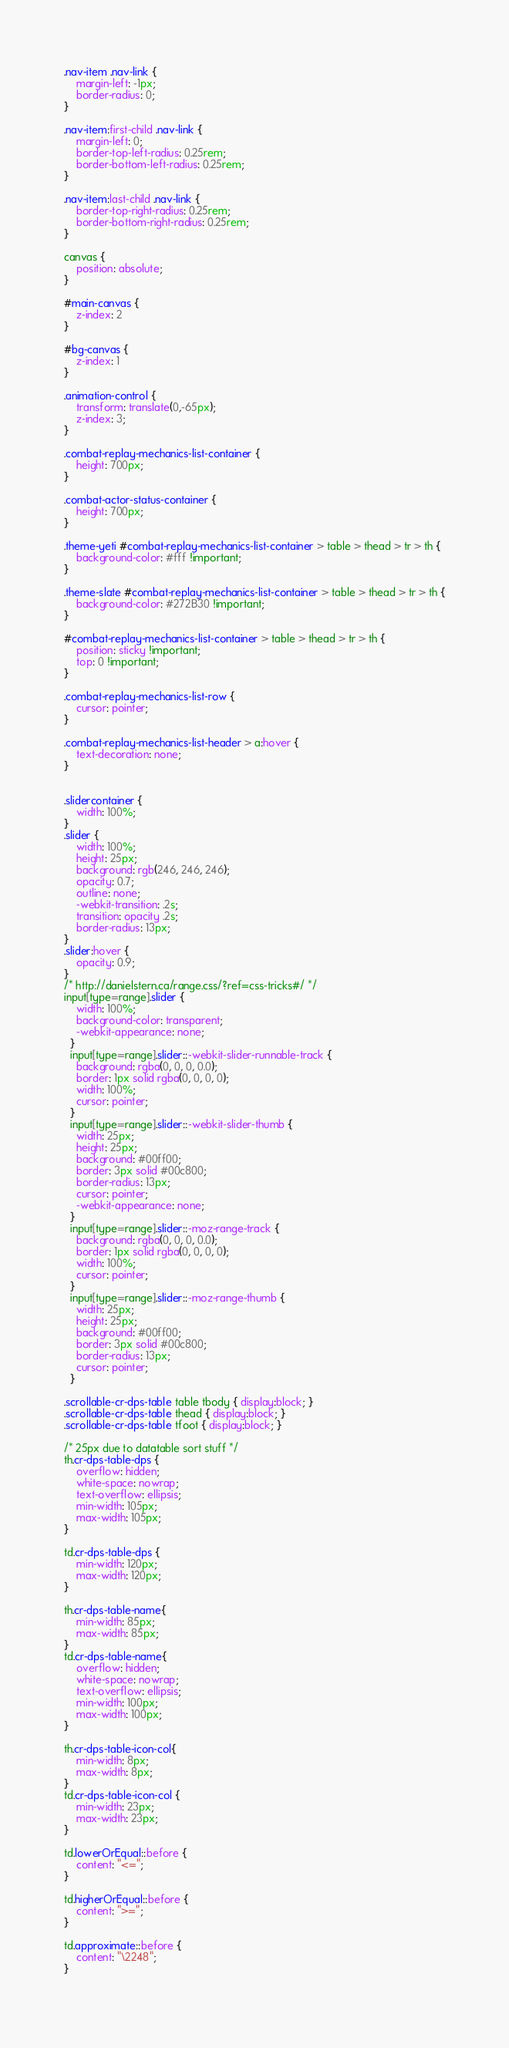Convert code to text. <code><loc_0><loc_0><loc_500><loc_500><_CSS_>.nav-item .nav-link {
    margin-left: -1px;
    border-radius: 0;
}

.nav-item:first-child .nav-link {
    margin-left: 0;
    border-top-left-radius: 0.25rem;
    border-bottom-left-radius: 0.25rem;
}

.nav-item:last-child .nav-link {
    border-top-right-radius: 0.25rem;
    border-bottom-right-radius: 0.25rem;
}

canvas {
    position: absolute;
}

#main-canvas {
    z-index: 2
}

#bg-canvas {
    z-index: 1
}

.animation-control {
    transform: translate(0,-65px);
    z-index: 3;
}

.combat-replay-mechanics-list-container {
    height: 700px;
}

.combat-actor-status-container {
    height: 700px;
}

.theme-yeti #combat-replay-mechanics-list-container > table > thead > tr > th {
    background-color: #fff !important;
}

.theme-slate #combat-replay-mechanics-list-container > table > thead > tr > th {
    background-color: #272B30 !important;
}

#combat-replay-mechanics-list-container > table > thead > tr > th {
    position: sticky !important;
    top: 0 !important;
}

.combat-replay-mechanics-list-row {
    cursor: pointer;
}

.combat-replay-mechanics-list-header > a:hover {
    text-decoration: none;
}


.slidercontainer {
    width: 100%;
}
.slider {
    width: 100%;
    height: 25px;
    background: rgb(246, 246, 246);
    opacity: 0.7;
    outline: none;
    -webkit-transition: .2s;
    transition: opacity .2s;
    border-radius: 13px;
}
.slider:hover {
    opacity: 0.9;
}
/* http://danielstern.ca/range.css/?ref=css-tricks#/ */
input[type=range].slider {
    width: 100%;
    background-color: transparent;
    -webkit-appearance: none;
  }
  input[type=range].slider::-webkit-slider-runnable-track {
    background: rgba(0, 0, 0, 0.0);
    border: 1px solid rgba(0, 0, 0, 0);
    width: 100%;
    cursor: pointer;
  }
  input[type=range].slider::-webkit-slider-thumb {
    width: 25px;
    height: 25px;
    background: #00ff00;
    border: 3px solid #00c800;
    border-radius: 13px;
    cursor: pointer;
    -webkit-appearance: none;
  }
  input[type=range].slider::-moz-range-track {
    background: rgba(0, 0, 0, 0.0);
    border: 1px solid rgba(0, 0, 0, 0);
    width: 100%;
    cursor: pointer;
  }
  input[type=range].slider::-moz-range-thumb {
    width: 25px;
    height: 25px;
    background: #00ff00;
    border: 3px solid #00c800;
    border-radius: 13px;
    cursor: pointer;
  }

.scrollable-cr-dps-table table tbody { display:block; }
.scrollable-cr-dps-table thead { display:block; }
.scrollable-cr-dps-table tfoot { display:block; }

/* 25px due to datatable sort stuff */
th.cr-dps-table-dps {
    overflow: hidden;
    white-space: nowrap;
    text-overflow: ellipsis;
    min-width: 105px;
    max-width: 105px;
}

td.cr-dps-table-dps {
    min-width: 120px;
    max-width: 120px;
}

th.cr-dps-table-name{
    min-width: 85px;
    max-width: 85px;
}
td.cr-dps-table-name{
    overflow: hidden;
    white-space: nowrap;
    text-overflow: ellipsis;
    min-width: 100px;
    max-width: 100px;
}

th.cr-dps-table-icon-col{
    min-width: 8px;
    max-width: 8px;
}
td.cr-dps-table-icon-col {   
    min-width: 23px;
    max-width: 23px;
}

td.lowerOrEqual::before {
    content: "<=";
}

td.higherOrEqual::before {
    content: ">=";
}

td.approximate::before {
    content: "\2248";
}
  </code> 